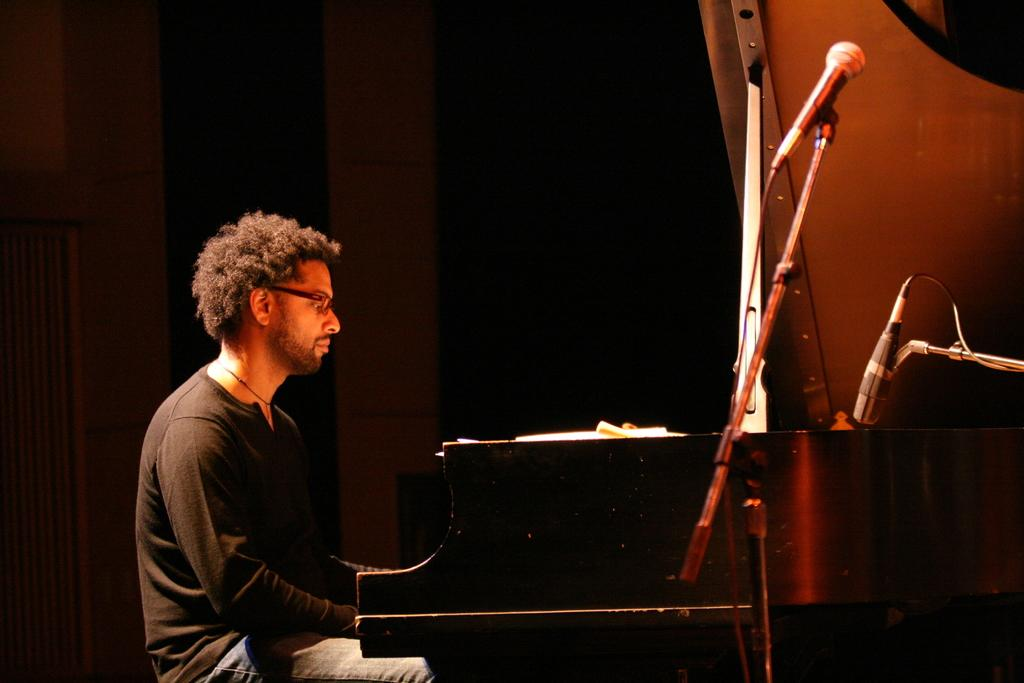What is the person in the image doing? The person is sitting on a stool. What is in front of the person? The person is in front of a piano. What objects are present that might be used for amplifying sound? There are microphones present. What type of squirrel can be seen sitting on the father's seat in the image? There is no squirrel or father present in the image, and therefore no such activity can be observed. 